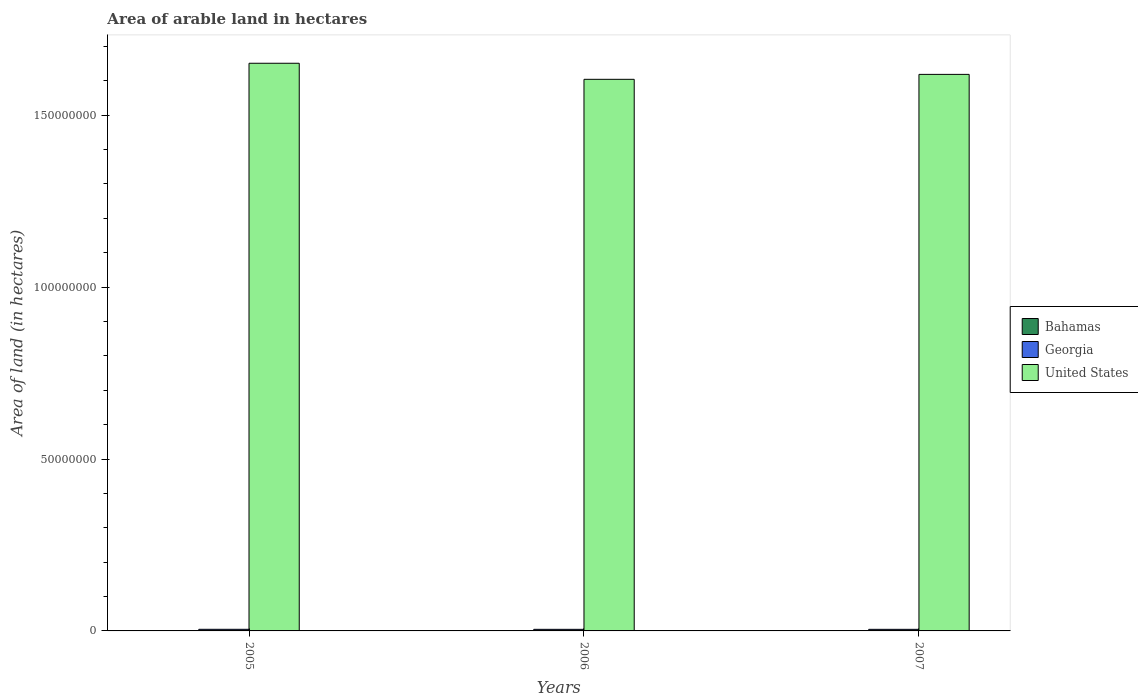How many groups of bars are there?
Provide a succinct answer. 3. Are the number of bars on each tick of the X-axis equal?
Provide a succinct answer. Yes. How many bars are there on the 1st tick from the left?
Keep it short and to the point. 3. What is the total arable land in United States in 2005?
Your answer should be compact. 1.65e+08. Across all years, what is the maximum total arable land in Bahamas?
Offer a very short reply. 7000. Across all years, what is the minimum total arable land in Bahamas?
Your response must be concise. 7000. In which year was the total arable land in United States maximum?
Give a very brief answer. 2005. In which year was the total arable land in Bahamas minimum?
Keep it short and to the point. 2005. What is the total total arable land in United States in the graph?
Offer a very short reply. 4.87e+08. What is the difference between the total arable land in United States in 2005 and that in 2007?
Your answer should be very brief. 3.24e+06. What is the difference between the total arable land in Georgia in 2005 and the total arable land in United States in 2006?
Your answer should be very brief. -1.60e+08. What is the average total arable land in United States per year?
Make the answer very short. 1.62e+08. In the year 2005, what is the difference between the total arable land in Bahamas and total arable land in Georgia?
Keep it short and to the point. -4.63e+05. In how many years, is the total arable land in United States greater than 10000000 hectares?
Your response must be concise. 3. What is the ratio of the total arable land in United States in 2005 to that in 2007?
Offer a very short reply. 1.02. Is the difference between the total arable land in Bahamas in 2005 and 2006 greater than the difference between the total arable land in Georgia in 2005 and 2006?
Your answer should be very brief. No. What is the difference between the highest and the second highest total arable land in Georgia?
Make the answer very short. 7000. What is the difference between the highest and the lowest total arable land in Georgia?
Provide a succinct answer. 8000. In how many years, is the total arable land in Georgia greater than the average total arable land in Georgia taken over all years?
Your answer should be very brief. 1. Is the sum of the total arable land in Bahamas in 2005 and 2006 greater than the maximum total arable land in Georgia across all years?
Give a very brief answer. No. What does the 2nd bar from the left in 2007 represents?
Provide a succinct answer. Georgia. How many bars are there?
Offer a terse response. 9. Are all the bars in the graph horizontal?
Offer a very short reply. No. Are the values on the major ticks of Y-axis written in scientific E-notation?
Keep it short and to the point. No. Does the graph contain any zero values?
Offer a very short reply. No. Where does the legend appear in the graph?
Provide a short and direct response. Center right. How many legend labels are there?
Your response must be concise. 3. How are the legend labels stacked?
Offer a very short reply. Vertical. What is the title of the graph?
Ensure brevity in your answer.  Area of arable land in hectares. Does "Sao Tome and Principe" appear as one of the legend labels in the graph?
Your response must be concise. No. What is the label or title of the X-axis?
Make the answer very short. Years. What is the label or title of the Y-axis?
Offer a very short reply. Area of land (in hectares). What is the Area of land (in hectares) of Bahamas in 2005?
Your response must be concise. 7000. What is the Area of land (in hectares) of United States in 2005?
Your answer should be compact. 1.65e+08. What is the Area of land (in hectares) of Bahamas in 2006?
Your response must be concise. 7000. What is the Area of land (in hectares) of Georgia in 2006?
Your answer should be very brief. 4.62e+05. What is the Area of land (in hectares) of United States in 2006?
Your response must be concise. 1.60e+08. What is the Area of land (in hectares) of Bahamas in 2007?
Ensure brevity in your answer.  7000. What is the Area of land (in hectares) of Georgia in 2007?
Offer a very short reply. 4.63e+05. What is the Area of land (in hectares) of United States in 2007?
Ensure brevity in your answer.  1.62e+08. Across all years, what is the maximum Area of land (in hectares) of Bahamas?
Give a very brief answer. 7000. Across all years, what is the maximum Area of land (in hectares) in Georgia?
Your response must be concise. 4.70e+05. Across all years, what is the maximum Area of land (in hectares) of United States?
Keep it short and to the point. 1.65e+08. Across all years, what is the minimum Area of land (in hectares) of Bahamas?
Your response must be concise. 7000. Across all years, what is the minimum Area of land (in hectares) in Georgia?
Offer a very short reply. 4.62e+05. Across all years, what is the minimum Area of land (in hectares) of United States?
Provide a short and direct response. 1.60e+08. What is the total Area of land (in hectares) in Bahamas in the graph?
Offer a terse response. 2.10e+04. What is the total Area of land (in hectares) in Georgia in the graph?
Offer a terse response. 1.40e+06. What is the total Area of land (in hectares) of United States in the graph?
Keep it short and to the point. 4.87e+08. What is the difference between the Area of land (in hectares) in Georgia in 2005 and that in 2006?
Ensure brevity in your answer.  8000. What is the difference between the Area of land (in hectares) of United States in 2005 and that in 2006?
Ensure brevity in your answer.  4.67e+06. What is the difference between the Area of land (in hectares) of Georgia in 2005 and that in 2007?
Give a very brief answer. 7000. What is the difference between the Area of land (in hectares) of United States in 2005 and that in 2007?
Ensure brevity in your answer.  3.24e+06. What is the difference between the Area of land (in hectares) in Bahamas in 2006 and that in 2007?
Your answer should be very brief. 0. What is the difference between the Area of land (in hectares) in Georgia in 2006 and that in 2007?
Offer a terse response. -1000. What is the difference between the Area of land (in hectares) of United States in 2006 and that in 2007?
Your answer should be very brief. -1.44e+06. What is the difference between the Area of land (in hectares) of Bahamas in 2005 and the Area of land (in hectares) of Georgia in 2006?
Your answer should be compact. -4.55e+05. What is the difference between the Area of land (in hectares) of Bahamas in 2005 and the Area of land (in hectares) of United States in 2006?
Offer a very short reply. -1.60e+08. What is the difference between the Area of land (in hectares) in Georgia in 2005 and the Area of land (in hectares) in United States in 2006?
Provide a succinct answer. -1.60e+08. What is the difference between the Area of land (in hectares) of Bahamas in 2005 and the Area of land (in hectares) of Georgia in 2007?
Offer a terse response. -4.56e+05. What is the difference between the Area of land (in hectares) of Bahamas in 2005 and the Area of land (in hectares) of United States in 2007?
Offer a very short reply. -1.62e+08. What is the difference between the Area of land (in hectares) in Georgia in 2005 and the Area of land (in hectares) in United States in 2007?
Offer a very short reply. -1.61e+08. What is the difference between the Area of land (in hectares) in Bahamas in 2006 and the Area of land (in hectares) in Georgia in 2007?
Offer a very short reply. -4.56e+05. What is the difference between the Area of land (in hectares) of Bahamas in 2006 and the Area of land (in hectares) of United States in 2007?
Your response must be concise. -1.62e+08. What is the difference between the Area of land (in hectares) of Georgia in 2006 and the Area of land (in hectares) of United States in 2007?
Your response must be concise. -1.61e+08. What is the average Area of land (in hectares) in Bahamas per year?
Make the answer very short. 7000. What is the average Area of land (in hectares) of Georgia per year?
Your answer should be compact. 4.65e+05. What is the average Area of land (in hectares) of United States per year?
Make the answer very short. 1.62e+08. In the year 2005, what is the difference between the Area of land (in hectares) of Bahamas and Area of land (in hectares) of Georgia?
Ensure brevity in your answer.  -4.63e+05. In the year 2005, what is the difference between the Area of land (in hectares) of Bahamas and Area of land (in hectares) of United States?
Offer a terse response. -1.65e+08. In the year 2005, what is the difference between the Area of land (in hectares) in Georgia and Area of land (in hectares) in United States?
Give a very brief answer. -1.65e+08. In the year 2006, what is the difference between the Area of land (in hectares) of Bahamas and Area of land (in hectares) of Georgia?
Your response must be concise. -4.55e+05. In the year 2006, what is the difference between the Area of land (in hectares) in Bahamas and Area of land (in hectares) in United States?
Offer a very short reply. -1.60e+08. In the year 2006, what is the difference between the Area of land (in hectares) of Georgia and Area of land (in hectares) of United States?
Give a very brief answer. -1.60e+08. In the year 2007, what is the difference between the Area of land (in hectares) in Bahamas and Area of land (in hectares) in Georgia?
Make the answer very short. -4.56e+05. In the year 2007, what is the difference between the Area of land (in hectares) of Bahamas and Area of land (in hectares) of United States?
Offer a very short reply. -1.62e+08. In the year 2007, what is the difference between the Area of land (in hectares) of Georgia and Area of land (in hectares) of United States?
Provide a short and direct response. -1.61e+08. What is the ratio of the Area of land (in hectares) in Bahamas in 2005 to that in 2006?
Offer a very short reply. 1. What is the ratio of the Area of land (in hectares) in Georgia in 2005 to that in 2006?
Make the answer very short. 1.02. What is the ratio of the Area of land (in hectares) of United States in 2005 to that in 2006?
Your answer should be very brief. 1.03. What is the ratio of the Area of land (in hectares) in Bahamas in 2005 to that in 2007?
Your answer should be very brief. 1. What is the ratio of the Area of land (in hectares) of Georgia in 2005 to that in 2007?
Your response must be concise. 1.02. What is the ratio of the Area of land (in hectares) in United States in 2005 to that in 2007?
Make the answer very short. 1.02. What is the difference between the highest and the second highest Area of land (in hectares) of Bahamas?
Ensure brevity in your answer.  0. What is the difference between the highest and the second highest Area of land (in hectares) of Georgia?
Your response must be concise. 7000. What is the difference between the highest and the second highest Area of land (in hectares) of United States?
Provide a short and direct response. 3.24e+06. What is the difference between the highest and the lowest Area of land (in hectares) in Bahamas?
Provide a succinct answer. 0. What is the difference between the highest and the lowest Area of land (in hectares) in Georgia?
Give a very brief answer. 8000. What is the difference between the highest and the lowest Area of land (in hectares) in United States?
Provide a short and direct response. 4.67e+06. 